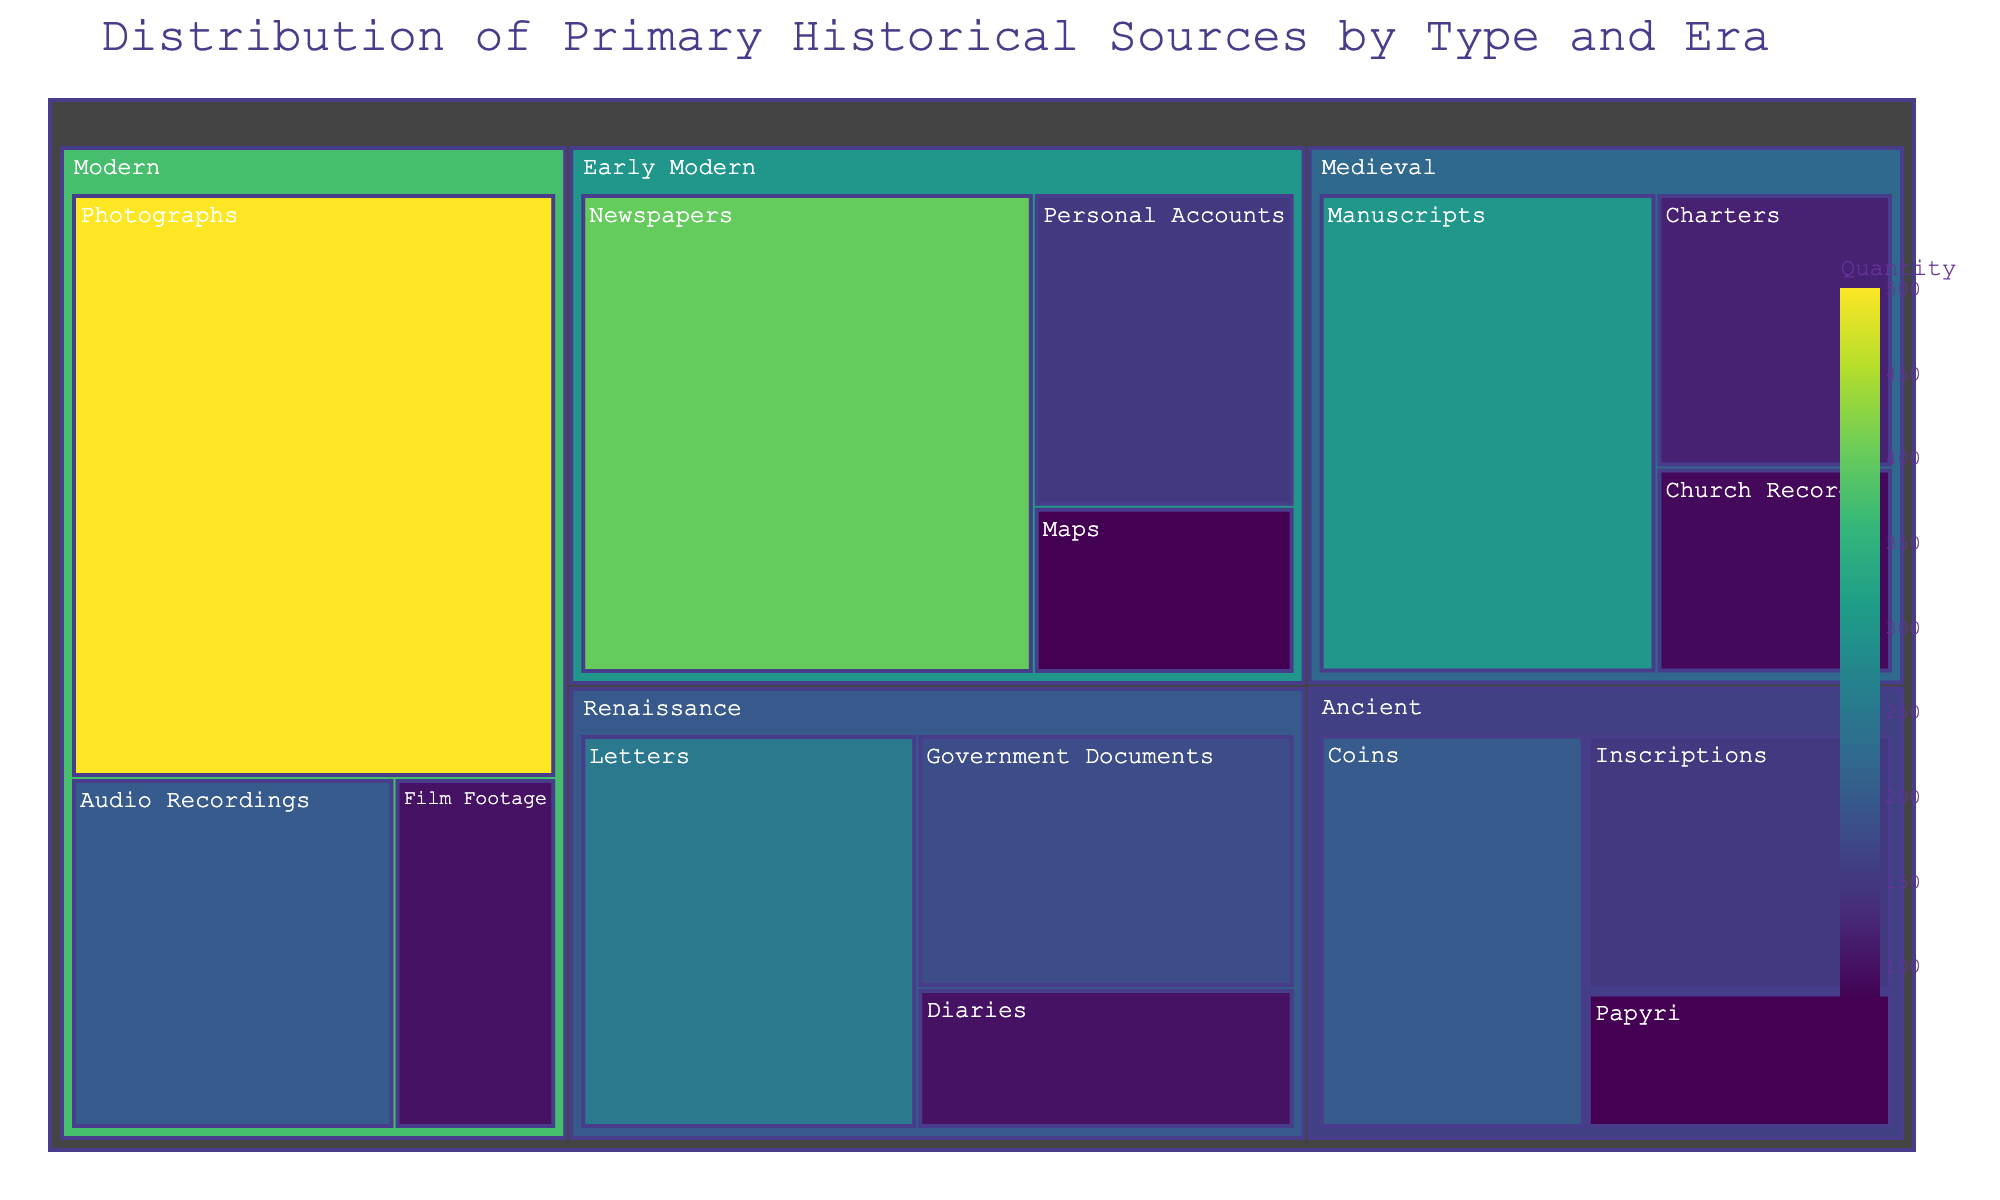What is the title of the treemap? The title of the treemap is usually found at the top of the visual. It provides a summary of the data displayed. In this case, the title is indicated as 'Distribution of Primary Historical Sources by Type and Era' from the code.
Answer: Distribution of Primary Historical Sources by Type and Era Which era has the highest quantity of primary sources? To answer this, we compare the values for each era. Summing the quantities for each era shows that the Modern era has the highest quantity (500 + 200 + 100 = 800).
Answer: Modern What is the total quantity of primary sources from the Ancient era? We sum the values of all types in the Ancient era, which are Inscriptions (150), Papyri (80), and Coins (200). Therefore, 150 + 80 + 200 = 430.
Answer: 430 Which type of primary source in the Renaissance era has the largest quantity? We need to look at the values for 'Letters', 'Diaries', and 'Government Documents' in the Renaissance era. The values are 250, 100, and 180 respectively. 'Letters' has the largest quantity.
Answer: Letters What is the difference in the quantity between Inscriptions and Coins in the Ancient era? In the Ancient era, Inscriptions have a quantity of 150, and Coins have 200. The difference is calculated as 200 - 150 = 50.
Answer: 50 How does the quantity of Manuscripts in the Medieval era compare to that of Newspapers in the Early Modern era? Manuscripts in the Medieval era have a quantity of 300, while Newspapers in the Early Modern era have 400. Newspapers have a higher quantity by 400 - 300 = 100.
Answer: Newspapers have 100 more What primary source type has the smallest quantity in the Early Modern era? We look at the quantities of 'Newspapers', 'Personal Accounts', and 'Maps' in the Early Modern era. These quantities are 400, 150, and 80 respectively. 'Maps' has the smallest quantity.
Answer: Maps What is the combined quantity of primary sources in the Medieval and Renaissance eras? We sum the totals of both eras. Medieval era: 300 (Manuscripts) + 120 (Charters) + 90 (Church Records) = 510. Renaissance era: 250 (Letters) + 100 (Diaries) + 180 (Government Documents) = 530. The combined total is 510 + 530 = 1040.
Answer: 1040 Which era has more variety in types of primary sources: Medieval or Modern? Count the different types in each era. Medieval era has Manuscripts, Charters, and Church Records (3 types). Modern era has Photographs, Audio Recordings, and Film Footage (3 types). Both eras have the same variety.
Answer: Both have the same variety What is the relative size of the section for Photographs compared to the entire treemap? The total quantity of sources is the sum for all eras. Total = 430 (Ancient) + 510 (Medieval) + 530 (Renaissance) + 630 (Early Modern) + 800 (Modern) = 2900. Photographs form 500/2900 of the total (which is approximately 17.2%).
Answer: Approximately 17.2% 